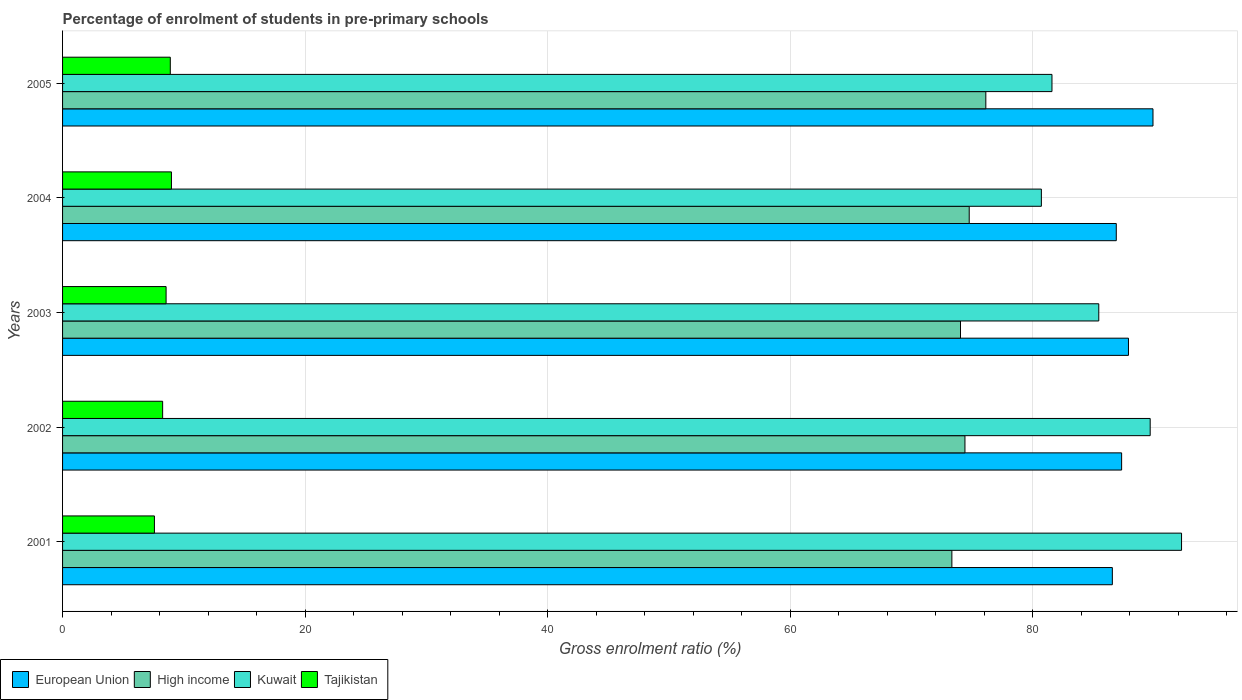How many different coloured bars are there?
Keep it short and to the point. 4. How many groups of bars are there?
Offer a very short reply. 5. Are the number of bars per tick equal to the number of legend labels?
Provide a short and direct response. Yes. Are the number of bars on each tick of the Y-axis equal?
Offer a terse response. Yes. What is the label of the 4th group of bars from the top?
Provide a short and direct response. 2002. What is the percentage of students enrolled in pre-primary schools in High income in 2002?
Offer a terse response. 74.41. Across all years, what is the maximum percentage of students enrolled in pre-primary schools in European Union?
Your response must be concise. 89.91. Across all years, what is the minimum percentage of students enrolled in pre-primary schools in European Union?
Offer a very short reply. 86.56. In which year was the percentage of students enrolled in pre-primary schools in Kuwait maximum?
Give a very brief answer. 2001. What is the total percentage of students enrolled in pre-primary schools in European Union in the graph?
Your answer should be very brief. 438.56. What is the difference between the percentage of students enrolled in pre-primary schools in European Union in 2001 and that in 2004?
Provide a short and direct response. -0.32. What is the difference between the percentage of students enrolled in pre-primary schools in Kuwait in 2003 and the percentage of students enrolled in pre-primary schools in High income in 2002?
Offer a very short reply. 11.04. What is the average percentage of students enrolled in pre-primary schools in Kuwait per year?
Provide a short and direct response. 85.93. In the year 2003, what is the difference between the percentage of students enrolled in pre-primary schools in Tajikistan and percentage of students enrolled in pre-primary schools in European Union?
Your answer should be very brief. -79.35. What is the ratio of the percentage of students enrolled in pre-primary schools in European Union in 2001 to that in 2005?
Your answer should be compact. 0.96. What is the difference between the highest and the second highest percentage of students enrolled in pre-primary schools in High income?
Provide a short and direct response. 1.37. What is the difference between the highest and the lowest percentage of students enrolled in pre-primary schools in Kuwait?
Your answer should be very brief. 11.56. Is the sum of the percentage of students enrolled in pre-primary schools in Kuwait in 2002 and 2003 greater than the maximum percentage of students enrolled in pre-primary schools in European Union across all years?
Your response must be concise. Yes. Is it the case that in every year, the sum of the percentage of students enrolled in pre-primary schools in High income and percentage of students enrolled in pre-primary schools in Kuwait is greater than the sum of percentage of students enrolled in pre-primary schools in Tajikistan and percentage of students enrolled in pre-primary schools in European Union?
Provide a short and direct response. No. What does the 1st bar from the top in 2001 represents?
Give a very brief answer. Tajikistan. What does the 3rd bar from the bottom in 2005 represents?
Give a very brief answer. Kuwait. How many bars are there?
Provide a succinct answer. 20. What is the difference between two consecutive major ticks on the X-axis?
Ensure brevity in your answer.  20. What is the title of the graph?
Your answer should be very brief. Percentage of enrolment of students in pre-primary schools. Does "Liberia" appear as one of the legend labels in the graph?
Offer a terse response. No. What is the label or title of the X-axis?
Keep it short and to the point. Gross enrolment ratio (%). What is the Gross enrolment ratio (%) in European Union in 2001?
Provide a succinct answer. 86.56. What is the Gross enrolment ratio (%) in High income in 2001?
Provide a succinct answer. 73.33. What is the Gross enrolment ratio (%) in Kuwait in 2001?
Keep it short and to the point. 92.26. What is the Gross enrolment ratio (%) of Tajikistan in 2001?
Offer a terse response. 7.57. What is the Gross enrolment ratio (%) in European Union in 2002?
Provide a succinct answer. 87.32. What is the Gross enrolment ratio (%) of High income in 2002?
Provide a short and direct response. 74.41. What is the Gross enrolment ratio (%) in Kuwait in 2002?
Offer a very short reply. 89.68. What is the Gross enrolment ratio (%) of Tajikistan in 2002?
Your response must be concise. 8.25. What is the Gross enrolment ratio (%) in European Union in 2003?
Give a very brief answer. 87.89. What is the Gross enrolment ratio (%) of High income in 2003?
Your answer should be very brief. 74.04. What is the Gross enrolment ratio (%) in Kuwait in 2003?
Provide a succinct answer. 85.44. What is the Gross enrolment ratio (%) of Tajikistan in 2003?
Provide a succinct answer. 8.54. What is the Gross enrolment ratio (%) of European Union in 2004?
Ensure brevity in your answer.  86.88. What is the Gross enrolment ratio (%) in High income in 2004?
Offer a very short reply. 74.76. What is the Gross enrolment ratio (%) of Kuwait in 2004?
Your answer should be compact. 80.71. What is the Gross enrolment ratio (%) in Tajikistan in 2004?
Make the answer very short. 8.98. What is the Gross enrolment ratio (%) of European Union in 2005?
Give a very brief answer. 89.91. What is the Gross enrolment ratio (%) of High income in 2005?
Offer a terse response. 76.13. What is the Gross enrolment ratio (%) of Kuwait in 2005?
Offer a terse response. 81.58. What is the Gross enrolment ratio (%) in Tajikistan in 2005?
Provide a short and direct response. 8.88. Across all years, what is the maximum Gross enrolment ratio (%) of European Union?
Offer a very short reply. 89.91. Across all years, what is the maximum Gross enrolment ratio (%) of High income?
Provide a succinct answer. 76.13. Across all years, what is the maximum Gross enrolment ratio (%) of Kuwait?
Your answer should be very brief. 92.26. Across all years, what is the maximum Gross enrolment ratio (%) of Tajikistan?
Your response must be concise. 8.98. Across all years, what is the minimum Gross enrolment ratio (%) of European Union?
Offer a terse response. 86.56. Across all years, what is the minimum Gross enrolment ratio (%) of High income?
Give a very brief answer. 73.33. Across all years, what is the minimum Gross enrolment ratio (%) in Kuwait?
Your answer should be compact. 80.71. Across all years, what is the minimum Gross enrolment ratio (%) of Tajikistan?
Offer a terse response. 7.57. What is the total Gross enrolment ratio (%) in European Union in the graph?
Provide a short and direct response. 438.56. What is the total Gross enrolment ratio (%) of High income in the graph?
Your answer should be compact. 372.66. What is the total Gross enrolment ratio (%) in Kuwait in the graph?
Offer a terse response. 429.67. What is the total Gross enrolment ratio (%) of Tajikistan in the graph?
Provide a succinct answer. 42.22. What is the difference between the Gross enrolment ratio (%) in European Union in 2001 and that in 2002?
Make the answer very short. -0.77. What is the difference between the Gross enrolment ratio (%) in High income in 2001 and that in 2002?
Your response must be concise. -1.08. What is the difference between the Gross enrolment ratio (%) of Kuwait in 2001 and that in 2002?
Ensure brevity in your answer.  2.59. What is the difference between the Gross enrolment ratio (%) in Tajikistan in 2001 and that in 2002?
Your response must be concise. -0.68. What is the difference between the Gross enrolment ratio (%) in European Union in 2001 and that in 2003?
Your response must be concise. -1.33. What is the difference between the Gross enrolment ratio (%) of High income in 2001 and that in 2003?
Provide a succinct answer. -0.71. What is the difference between the Gross enrolment ratio (%) of Kuwait in 2001 and that in 2003?
Offer a very short reply. 6.82. What is the difference between the Gross enrolment ratio (%) in Tajikistan in 2001 and that in 2003?
Ensure brevity in your answer.  -0.96. What is the difference between the Gross enrolment ratio (%) in European Union in 2001 and that in 2004?
Provide a short and direct response. -0.32. What is the difference between the Gross enrolment ratio (%) of High income in 2001 and that in 2004?
Your answer should be very brief. -1.43. What is the difference between the Gross enrolment ratio (%) of Kuwait in 2001 and that in 2004?
Ensure brevity in your answer.  11.56. What is the difference between the Gross enrolment ratio (%) in Tajikistan in 2001 and that in 2004?
Keep it short and to the point. -1.4. What is the difference between the Gross enrolment ratio (%) in European Union in 2001 and that in 2005?
Provide a succinct answer. -3.35. What is the difference between the Gross enrolment ratio (%) of High income in 2001 and that in 2005?
Provide a succinct answer. -2.8. What is the difference between the Gross enrolment ratio (%) of Kuwait in 2001 and that in 2005?
Provide a succinct answer. 10.68. What is the difference between the Gross enrolment ratio (%) in Tajikistan in 2001 and that in 2005?
Provide a succinct answer. -1.31. What is the difference between the Gross enrolment ratio (%) of European Union in 2002 and that in 2003?
Offer a terse response. -0.56. What is the difference between the Gross enrolment ratio (%) in High income in 2002 and that in 2003?
Provide a short and direct response. 0.37. What is the difference between the Gross enrolment ratio (%) in Kuwait in 2002 and that in 2003?
Offer a very short reply. 4.24. What is the difference between the Gross enrolment ratio (%) of Tajikistan in 2002 and that in 2003?
Your answer should be very brief. -0.28. What is the difference between the Gross enrolment ratio (%) of European Union in 2002 and that in 2004?
Provide a short and direct response. 0.44. What is the difference between the Gross enrolment ratio (%) of High income in 2002 and that in 2004?
Your answer should be very brief. -0.35. What is the difference between the Gross enrolment ratio (%) in Kuwait in 2002 and that in 2004?
Provide a succinct answer. 8.97. What is the difference between the Gross enrolment ratio (%) of Tajikistan in 2002 and that in 2004?
Your answer should be very brief. -0.72. What is the difference between the Gross enrolment ratio (%) of European Union in 2002 and that in 2005?
Offer a very short reply. -2.59. What is the difference between the Gross enrolment ratio (%) of High income in 2002 and that in 2005?
Your answer should be compact. -1.72. What is the difference between the Gross enrolment ratio (%) in Kuwait in 2002 and that in 2005?
Your response must be concise. 8.1. What is the difference between the Gross enrolment ratio (%) in Tajikistan in 2002 and that in 2005?
Provide a succinct answer. -0.63. What is the difference between the Gross enrolment ratio (%) of High income in 2003 and that in 2004?
Keep it short and to the point. -0.72. What is the difference between the Gross enrolment ratio (%) in Kuwait in 2003 and that in 2004?
Offer a very short reply. 4.73. What is the difference between the Gross enrolment ratio (%) of Tajikistan in 2003 and that in 2004?
Provide a short and direct response. -0.44. What is the difference between the Gross enrolment ratio (%) in European Union in 2003 and that in 2005?
Make the answer very short. -2.02. What is the difference between the Gross enrolment ratio (%) in High income in 2003 and that in 2005?
Your answer should be compact. -2.09. What is the difference between the Gross enrolment ratio (%) in Kuwait in 2003 and that in 2005?
Your response must be concise. 3.86. What is the difference between the Gross enrolment ratio (%) of Tajikistan in 2003 and that in 2005?
Your response must be concise. -0.35. What is the difference between the Gross enrolment ratio (%) of European Union in 2004 and that in 2005?
Provide a succinct answer. -3.03. What is the difference between the Gross enrolment ratio (%) of High income in 2004 and that in 2005?
Give a very brief answer. -1.37. What is the difference between the Gross enrolment ratio (%) of Kuwait in 2004 and that in 2005?
Provide a succinct answer. -0.87. What is the difference between the Gross enrolment ratio (%) of Tajikistan in 2004 and that in 2005?
Your response must be concise. 0.09. What is the difference between the Gross enrolment ratio (%) in European Union in 2001 and the Gross enrolment ratio (%) in High income in 2002?
Your response must be concise. 12.15. What is the difference between the Gross enrolment ratio (%) in European Union in 2001 and the Gross enrolment ratio (%) in Kuwait in 2002?
Offer a terse response. -3.12. What is the difference between the Gross enrolment ratio (%) in European Union in 2001 and the Gross enrolment ratio (%) in Tajikistan in 2002?
Ensure brevity in your answer.  78.31. What is the difference between the Gross enrolment ratio (%) of High income in 2001 and the Gross enrolment ratio (%) of Kuwait in 2002?
Offer a very short reply. -16.35. What is the difference between the Gross enrolment ratio (%) in High income in 2001 and the Gross enrolment ratio (%) in Tajikistan in 2002?
Make the answer very short. 65.08. What is the difference between the Gross enrolment ratio (%) in Kuwait in 2001 and the Gross enrolment ratio (%) in Tajikistan in 2002?
Your response must be concise. 84.01. What is the difference between the Gross enrolment ratio (%) in European Union in 2001 and the Gross enrolment ratio (%) in High income in 2003?
Offer a terse response. 12.52. What is the difference between the Gross enrolment ratio (%) of European Union in 2001 and the Gross enrolment ratio (%) of Kuwait in 2003?
Offer a terse response. 1.12. What is the difference between the Gross enrolment ratio (%) in European Union in 2001 and the Gross enrolment ratio (%) in Tajikistan in 2003?
Provide a succinct answer. 78.02. What is the difference between the Gross enrolment ratio (%) in High income in 2001 and the Gross enrolment ratio (%) in Kuwait in 2003?
Provide a succinct answer. -12.11. What is the difference between the Gross enrolment ratio (%) in High income in 2001 and the Gross enrolment ratio (%) in Tajikistan in 2003?
Provide a short and direct response. 64.79. What is the difference between the Gross enrolment ratio (%) of Kuwait in 2001 and the Gross enrolment ratio (%) of Tajikistan in 2003?
Make the answer very short. 83.73. What is the difference between the Gross enrolment ratio (%) of European Union in 2001 and the Gross enrolment ratio (%) of High income in 2004?
Provide a succinct answer. 11.8. What is the difference between the Gross enrolment ratio (%) in European Union in 2001 and the Gross enrolment ratio (%) in Kuwait in 2004?
Offer a very short reply. 5.85. What is the difference between the Gross enrolment ratio (%) of European Union in 2001 and the Gross enrolment ratio (%) of Tajikistan in 2004?
Offer a very short reply. 77.58. What is the difference between the Gross enrolment ratio (%) in High income in 2001 and the Gross enrolment ratio (%) in Kuwait in 2004?
Make the answer very short. -7.38. What is the difference between the Gross enrolment ratio (%) in High income in 2001 and the Gross enrolment ratio (%) in Tajikistan in 2004?
Make the answer very short. 64.35. What is the difference between the Gross enrolment ratio (%) of Kuwait in 2001 and the Gross enrolment ratio (%) of Tajikistan in 2004?
Ensure brevity in your answer.  83.29. What is the difference between the Gross enrolment ratio (%) in European Union in 2001 and the Gross enrolment ratio (%) in High income in 2005?
Provide a succinct answer. 10.43. What is the difference between the Gross enrolment ratio (%) in European Union in 2001 and the Gross enrolment ratio (%) in Kuwait in 2005?
Your answer should be compact. 4.98. What is the difference between the Gross enrolment ratio (%) in European Union in 2001 and the Gross enrolment ratio (%) in Tajikistan in 2005?
Ensure brevity in your answer.  77.68. What is the difference between the Gross enrolment ratio (%) of High income in 2001 and the Gross enrolment ratio (%) of Kuwait in 2005?
Ensure brevity in your answer.  -8.25. What is the difference between the Gross enrolment ratio (%) of High income in 2001 and the Gross enrolment ratio (%) of Tajikistan in 2005?
Make the answer very short. 64.44. What is the difference between the Gross enrolment ratio (%) in Kuwait in 2001 and the Gross enrolment ratio (%) in Tajikistan in 2005?
Keep it short and to the point. 83.38. What is the difference between the Gross enrolment ratio (%) in European Union in 2002 and the Gross enrolment ratio (%) in High income in 2003?
Your response must be concise. 13.29. What is the difference between the Gross enrolment ratio (%) of European Union in 2002 and the Gross enrolment ratio (%) of Kuwait in 2003?
Keep it short and to the point. 1.88. What is the difference between the Gross enrolment ratio (%) of European Union in 2002 and the Gross enrolment ratio (%) of Tajikistan in 2003?
Your answer should be very brief. 78.79. What is the difference between the Gross enrolment ratio (%) of High income in 2002 and the Gross enrolment ratio (%) of Kuwait in 2003?
Make the answer very short. -11.04. What is the difference between the Gross enrolment ratio (%) of High income in 2002 and the Gross enrolment ratio (%) of Tajikistan in 2003?
Offer a very short reply. 65.87. What is the difference between the Gross enrolment ratio (%) of Kuwait in 2002 and the Gross enrolment ratio (%) of Tajikistan in 2003?
Your answer should be very brief. 81.14. What is the difference between the Gross enrolment ratio (%) of European Union in 2002 and the Gross enrolment ratio (%) of High income in 2004?
Your response must be concise. 12.57. What is the difference between the Gross enrolment ratio (%) of European Union in 2002 and the Gross enrolment ratio (%) of Kuwait in 2004?
Offer a terse response. 6.62. What is the difference between the Gross enrolment ratio (%) of European Union in 2002 and the Gross enrolment ratio (%) of Tajikistan in 2004?
Offer a very short reply. 78.35. What is the difference between the Gross enrolment ratio (%) of High income in 2002 and the Gross enrolment ratio (%) of Kuwait in 2004?
Offer a very short reply. -6.3. What is the difference between the Gross enrolment ratio (%) of High income in 2002 and the Gross enrolment ratio (%) of Tajikistan in 2004?
Provide a short and direct response. 65.43. What is the difference between the Gross enrolment ratio (%) of Kuwait in 2002 and the Gross enrolment ratio (%) of Tajikistan in 2004?
Your answer should be compact. 80.7. What is the difference between the Gross enrolment ratio (%) in European Union in 2002 and the Gross enrolment ratio (%) in High income in 2005?
Keep it short and to the point. 11.2. What is the difference between the Gross enrolment ratio (%) of European Union in 2002 and the Gross enrolment ratio (%) of Kuwait in 2005?
Your answer should be compact. 5.74. What is the difference between the Gross enrolment ratio (%) in European Union in 2002 and the Gross enrolment ratio (%) in Tajikistan in 2005?
Your answer should be compact. 78.44. What is the difference between the Gross enrolment ratio (%) of High income in 2002 and the Gross enrolment ratio (%) of Kuwait in 2005?
Ensure brevity in your answer.  -7.17. What is the difference between the Gross enrolment ratio (%) of High income in 2002 and the Gross enrolment ratio (%) of Tajikistan in 2005?
Provide a succinct answer. 65.52. What is the difference between the Gross enrolment ratio (%) of Kuwait in 2002 and the Gross enrolment ratio (%) of Tajikistan in 2005?
Your response must be concise. 80.8. What is the difference between the Gross enrolment ratio (%) of European Union in 2003 and the Gross enrolment ratio (%) of High income in 2004?
Your response must be concise. 13.13. What is the difference between the Gross enrolment ratio (%) in European Union in 2003 and the Gross enrolment ratio (%) in Kuwait in 2004?
Provide a short and direct response. 7.18. What is the difference between the Gross enrolment ratio (%) in European Union in 2003 and the Gross enrolment ratio (%) in Tajikistan in 2004?
Offer a very short reply. 78.91. What is the difference between the Gross enrolment ratio (%) of High income in 2003 and the Gross enrolment ratio (%) of Kuwait in 2004?
Make the answer very short. -6.67. What is the difference between the Gross enrolment ratio (%) in High income in 2003 and the Gross enrolment ratio (%) in Tajikistan in 2004?
Offer a terse response. 65.06. What is the difference between the Gross enrolment ratio (%) in Kuwait in 2003 and the Gross enrolment ratio (%) in Tajikistan in 2004?
Provide a succinct answer. 76.46. What is the difference between the Gross enrolment ratio (%) of European Union in 2003 and the Gross enrolment ratio (%) of High income in 2005?
Give a very brief answer. 11.76. What is the difference between the Gross enrolment ratio (%) of European Union in 2003 and the Gross enrolment ratio (%) of Kuwait in 2005?
Give a very brief answer. 6.31. What is the difference between the Gross enrolment ratio (%) in European Union in 2003 and the Gross enrolment ratio (%) in Tajikistan in 2005?
Your answer should be very brief. 79. What is the difference between the Gross enrolment ratio (%) in High income in 2003 and the Gross enrolment ratio (%) in Kuwait in 2005?
Give a very brief answer. -7.54. What is the difference between the Gross enrolment ratio (%) in High income in 2003 and the Gross enrolment ratio (%) in Tajikistan in 2005?
Offer a terse response. 65.16. What is the difference between the Gross enrolment ratio (%) of Kuwait in 2003 and the Gross enrolment ratio (%) of Tajikistan in 2005?
Provide a short and direct response. 76.56. What is the difference between the Gross enrolment ratio (%) of European Union in 2004 and the Gross enrolment ratio (%) of High income in 2005?
Offer a terse response. 10.76. What is the difference between the Gross enrolment ratio (%) of European Union in 2004 and the Gross enrolment ratio (%) of Kuwait in 2005?
Your answer should be compact. 5.3. What is the difference between the Gross enrolment ratio (%) of European Union in 2004 and the Gross enrolment ratio (%) of Tajikistan in 2005?
Give a very brief answer. 78. What is the difference between the Gross enrolment ratio (%) of High income in 2004 and the Gross enrolment ratio (%) of Kuwait in 2005?
Keep it short and to the point. -6.82. What is the difference between the Gross enrolment ratio (%) in High income in 2004 and the Gross enrolment ratio (%) in Tajikistan in 2005?
Offer a very short reply. 65.87. What is the difference between the Gross enrolment ratio (%) in Kuwait in 2004 and the Gross enrolment ratio (%) in Tajikistan in 2005?
Provide a short and direct response. 71.82. What is the average Gross enrolment ratio (%) of European Union per year?
Give a very brief answer. 87.71. What is the average Gross enrolment ratio (%) of High income per year?
Make the answer very short. 74.53. What is the average Gross enrolment ratio (%) in Kuwait per year?
Your response must be concise. 85.93. What is the average Gross enrolment ratio (%) of Tajikistan per year?
Keep it short and to the point. 8.44. In the year 2001, what is the difference between the Gross enrolment ratio (%) in European Union and Gross enrolment ratio (%) in High income?
Your response must be concise. 13.23. In the year 2001, what is the difference between the Gross enrolment ratio (%) in European Union and Gross enrolment ratio (%) in Kuwait?
Your answer should be compact. -5.71. In the year 2001, what is the difference between the Gross enrolment ratio (%) of European Union and Gross enrolment ratio (%) of Tajikistan?
Offer a very short reply. 78.99. In the year 2001, what is the difference between the Gross enrolment ratio (%) in High income and Gross enrolment ratio (%) in Kuwait?
Provide a succinct answer. -18.94. In the year 2001, what is the difference between the Gross enrolment ratio (%) of High income and Gross enrolment ratio (%) of Tajikistan?
Give a very brief answer. 65.75. In the year 2001, what is the difference between the Gross enrolment ratio (%) in Kuwait and Gross enrolment ratio (%) in Tajikistan?
Provide a succinct answer. 84.69. In the year 2002, what is the difference between the Gross enrolment ratio (%) in European Union and Gross enrolment ratio (%) in High income?
Your answer should be compact. 12.92. In the year 2002, what is the difference between the Gross enrolment ratio (%) of European Union and Gross enrolment ratio (%) of Kuwait?
Make the answer very short. -2.35. In the year 2002, what is the difference between the Gross enrolment ratio (%) of European Union and Gross enrolment ratio (%) of Tajikistan?
Offer a very short reply. 79.07. In the year 2002, what is the difference between the Gross enrolment ratio (%) of High income and Gross enrolment ratio (%) of Kuwait?
Ensure brevity in your answer.  -15.27. In the year 2002, what is the difference between the Gross enrolment ratio (%) in High income and Gross enrolment ratio (%) in Tajikistan?
Your response must be concise. 66.15. In the year 2002, what is the difference between the Gross enrolment ratio (%) in Kuwait and Gross enrolment ratio (%) in Tajikistan?
Offer a very short reply. 81.43. In the year 2003, what is the difference between the Gross enrolment ratio (%) in European Union and Gross enrolment ratio (%) in High income?
Make the answer very short. 13.85. In the year 2003, what is the difference between the Gross enrolment ratio (%) of European Union and Gross enrolment ratio (%) of Kuwait?
Offer a terse response. 2.45. In the year 2003, what is the difference between the Gross enrolment ratio (%) of European Union and Gross enrolment ratio (%) of Tajikistan?
Keep it short and to the point. 79.35. In the year 2003, what is the difference between the Gross enrolment ratio (%) of High income and Gross enrolment ratio (%) of Kuwait?
Offer a very short reply. -11.4. In the year 2003, what is the difference between the Gross enrolment ratio (%) of High income and Gross enrolment ratio (%) of Tajikistan?
Offer a very short reply. 65.5. In the year 2003, what is the difference between the Gross enrolment ratio (%) in Kuwait and Gross enrolment ratio (%) in Tajikistan?
Your answer should be compact. 76.91. In the year 2004, what is the difference between the Gross enrolment ratio (%) in European Union and Gross enrolment ratio (%) in High income?
Give a very brief answer. 12.13. In the year 2004, what is the difference between the Gross enrolment ratio (%) of European Union and Gross enrolment ratio (%) of Kuwait?
Your answer should be compact. 6.18. In the year 2004, what is the difference between the Gross enrolment ratio (%) in European Union and Gross enrolment ratio (%) in Tajikistan?
Give a very brief answer. 77.91. In the year 2004, what is the difference between the Gross enrolment ratio (%) of High income and Gross enrolment ratio (%) of Kuwait?
Give a very brief answer. -5.95. In the year 2004, what is the difference between the Gross enrolment ratio (%) in High income and Gross enrolment ratio (%) in Tajikistan?
Offer a very short reply. 65.78. In the year 2004, what is the difference between the Gross enrolment ratio (%) in Kuwait and Gross enrolment ratio (%) in Tajikistan?
Provide a succinct answer. 71.73. In the year 2005, what is the difference between the Gross enrolment ratio (%) in European Union and Gross enrolment ratio (%) in High income?
Keep it short and to the point. 13.78. In the year 2005, what is the difference between the Gross enrolment ratio (%) in European Union and Gross enrolment ratio (%) in Kuwait?
Provide a succinct answer. 8.33. In the year 2005, what is the difference between the Gross enrolment ratio (%) of European Union and Gross enrolment ratio (%) of Tajikistan?
Keep it short and to the point. 81.03. In the year 2005, what is the difference between the Gross enrolment ratio (%) of High income and Gross enrolment ratio (%) of Kuwait?
Provide a succinct answer. -5.45. In the year 2005, what is the difference between the Gross enrolment ratio (%) of High income and Gross enrolment ratio (%) of Tajikistan?
Make the answer very short. 67.24. In the year 2005, what is the difference between the Gross enrolment ratio (%) in Kuwait and Gross enrolment ratio (%) in Tajikistan?
Offer a very short reply. 72.7. What is the ratio of the Gross enrolment ratio (%) in High income in 2001 to that in 2002?
Your answer should be compact. 0.99. What is the ratio of the Gross enrolment ratio (%) of Kuwait in 2001 to that in 2002?
Offer a very short reply. 1.03. What is the ratio of the Gross enrolment ratio (%) of Tajikistan in 2001 to that in 2002?
Provide a succinct answer. 0.92. What is the ratio of the Gross enrolment ratio (%) of European Union in 2001 to that in 2003?
Ensure brevity in your answer.  0.98. What is the ratio of the Gross enrolment ratio (%) of Kuwait in 2001 to that in 2003?
Provide a succinct answer. 1.08. What is the ratio of the Gross enrolment ratio (%) in Tajikistan in 2001 to that in 2003?
Provide a succinct answer. 0.89. What is the ratio of the Gross enrolment ratio (%) in European Union in 2001 to that in 2004?
Keep it short and to the point. 1. What is the ratio of the Gross enrolment ratio (%) in High income in 2001 to that in 2004?
Your answer should be compact. 0.98. What is the ratio of the Gross enrolment ratio (%) in Kuwait in 2001 to that in 2004?
Your answer should be compact. 1.14. What is the ratio of the Gross enrolment ratio (%) of Tajikistan in 2001 to that in 2004?
Keep it short and to the point. 0.84. What is the ratio of the Gross enrolment ratio (%) of European Union in 2001 to that in 2005?
Offer a very short reply. 0.96. What is the ratio of the Gross enrolment ratio (%) in High income in 2001 to that in 2005?
Offer a very short reply. 0.96. What is the ratio of the Gross enrolment ratio (%) in Kuwait in 2001 to that in 2005?
Your answer should be very brief. 1.13. What is the ratio of the Gross enrolment ratio (%) of Tajikistan in 2001 to that in 2005?
Make the answer very short. 0.85. What is the ratio of the Gross enrolment ratio (%) in Kuwait in 2002 to that in 2003?
Ensure brevity in your answer.  1.05. What is the ratio of the Gross enrolment ratio (%) in Tajikistan in 2002 to that in 2003?
Ensure brevity in your answer.  0.97. What is the ratio of the Gross enrolment ratio (%) of European Union in 2002 to that in 2004?
Keep it short and to the point. 1.01. What is the ratio of the Gross enrolment ratio (%) in Kuwait in 2002 to that in 2004?
Your answer should be compact. 1.11. What is the ratio of the Gross enrolment ratio (%) in Tajikistan in 2002 to that in 2004?
Make the answer very short. 0.92. What is the ratio of the Gross enrolment ratio (%) in European Union in 2002 to that in 2005?
Make the answer very short. 0.97. What is the ratio of the Gross enrolment ratio (%) in High income in 2002 to that in 2005?
Provide a succinct answer. 0.98. What is the ratio of the Gross enrolment ratio (%) of Kuwait in 2002 to that in 2005?
Give a very brief answer. 1.1. What is the ratio of the Gross enrolment ratio (%) in Tajikistan in 2002 to that in 2005?
Provide a succinct answer. 0.93. What is the ratio of the Gross enrolment ratio (%) of European Union in 2003 to that in 2004?
Offer a terse response. 1.01. What is the ratio of the Gross enrolment ratio (%) in High income in 2003 to that in 2004?
Make the answer very short. 0.99. What is the ratio of the Gross enrolment ratio (%) in Kuwait in 2003 to that in 2004?
Make the answer very short. 1.06. What is the ratio of the Gross enrolment ratio (%) in Tajikistan in 2003 to that in 2004?
Offer a very short reply. 0.95. What is the ratio of the Gross enrolment ratio (%) of European Union in 2003 to that in 2005?
Make the answer very short. 0.98. What is the ratio of the Gross enrolment ratio (%) in High income in 2003 to that in 2005?
Your answer should be compact. 0.97. What is the ratio of the Gross enrolment ratio (%) of Kuwait in 2003 to that in 2005?
Give a very brief answer. 1.05. What is the ratio of the Gross enrolment ratio (%) in Tajikistan in 2003 to that in 2005?
Give a very brief answer. 0.96. What is the ratio of the Gross enrolment ratio (%) of European Union in 2004 to that in 2005?
Keep it short and to the point. 0.97. What is the ratio of the Gross enrolment ratio (%) of Kuwait in 2004 to that in 2005?
Offer a terse response. 0.99. What is the ratio of the Gross enrolment ratio (%) in Tajikistan in 2004 to that in 2005?
Provide a succinct answer. 1.01. What is the difference between the highest and the second highest Gross enrolment ratio (%) in European Union?
Provide a short and direct response. 2.02. What is the difference between the highest and the second highest Gross enrolment ratio (%) of High income?
Offer a terse response. 1.37. What is the difference between the highest and the second highest Gross enrolment ratio (%) in Kuwait?
Provide a short and direct response. 2.59. What is the difference between the highest and the second highest Gross enrolment ratio (%) of Tajikistan?
Keep it short and to the point. 0.09. What is the difference between the highest and the lowest Gross enrolment ratio (%) in European Union?
Ensure brevity in your answer.  3.35. What is the difference between the highest and the lowest Gross enrolment ratio (%) in High income?
Ensure brevity in your answer.  2.8. What is the difference between the highest and the lowest Gross enrolment ratio (%) of Kuwait?
Provide a succinct answer. 11.56. What is the difference between the highest and the lowest Gross enrolment ratio (%) of Tajikistan?
Give a very brief answer. 1.4. 